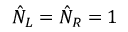Convert formula to latex. <formula><loc_0><loc_0><loc_500><loc_500>\hat { N } _ { L } = \hat { N } _ { R } = 1</formula> 